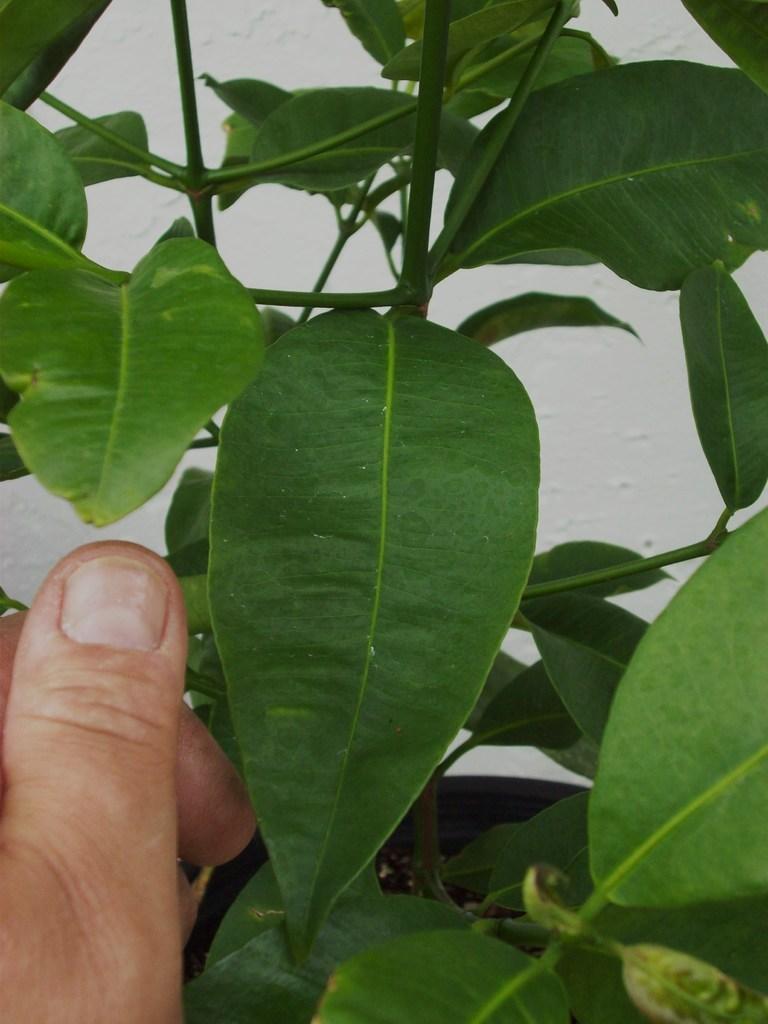In one or two sentences, can you explain what this image depicts? In this picture, there is a plant with leaves. At the bottom left, there is a hand. 